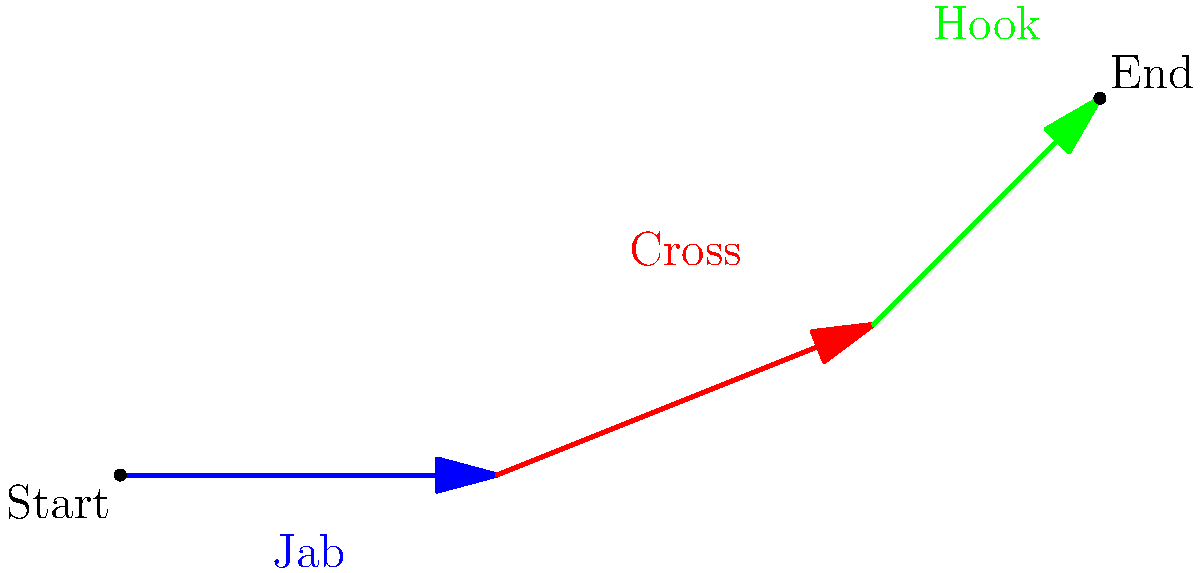Given the animated strike combination shown in the diagram, which of the following counter-attack moves would be most effective after the opponent's hook?

A) Slip and uppercut
B) Duck and body shot
C) Step back and leg kick
D) Takedown attempt To determine the most effective counter-attack move, we need to analyze the strike combination and consider the fighter's position after the final strike:

1. The combination starts with a jab (blue arrow), followed by a cross (red arrow), and ends with a hook (green arrow).

2. After throwing the hook, the opponent's position will be:
   - Their lead hand will be extended and high.
   - Their body will be slightly rotated, exposing their midsection.
   - Their weight will be shifted forward due to the momentum of the hook.

3. Considering these factors:
   - Option A (Slip and uppercut) could work, but the opponent's hand is already high, making it less effective.
   - Option B (Duck and body shot) takes advantage of the exposed midsection and the opponent's forward momentum.
   - Option C (Step back and leg kick) doesn't capitalize on the opponent's vulnerable position.
   - Option D (Takedown attempt) could be risky as the opponent's weight is forward, making it easier to sprawl.

4. The most effective counter-attack would be Option B (Duck and body shot) because:
   - Ducking avoids the hook if it hasn't fully connected.
   - The body shot targets the exposed midsection.
   - It takes advantage of the opponent's forward momentum, potentially off-balancing them.

Therefore, the duck and body shot combination provides the best opportunity to counter the given strike combination effectively.
Answer: B) Duck and body shot 